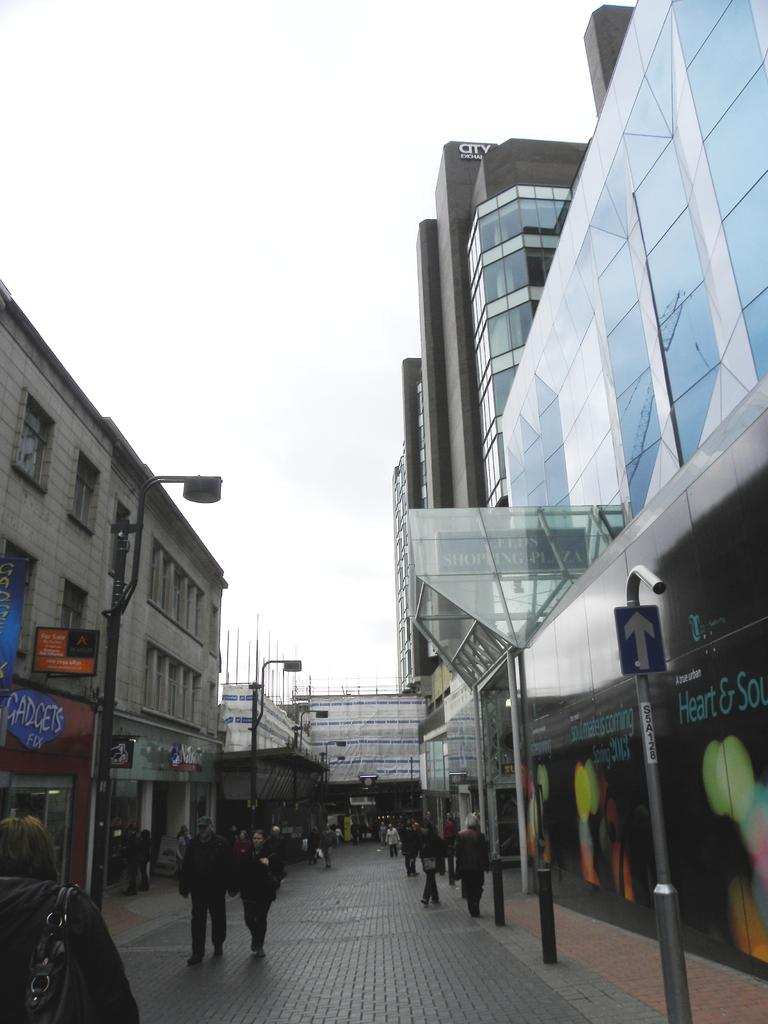What type of structures can be seen in the image? There are buildings in the image. Are there any living beings present in the image? Yes, there are people in the image. What objects can be seen in the image that are used for displaying information or advertisements? There are boards in the image. What can be seen in the image that provides illumination? There are lights in the image. What type of vertical structures can be seen in the image? There are poles in the image. What is visible in the background of the image? The sky is visible in the background of the image. Can you tell me how many bananas are hanging from the poles in the image? There are no bananas present in the image; it features buildings, people, boards, lights, poles, and a visible sky. What type of toys can be seen being played with by the people in the image? There are no toys visible in the image; it only shows people, buildings, boards, lights, poles, and the sky. 